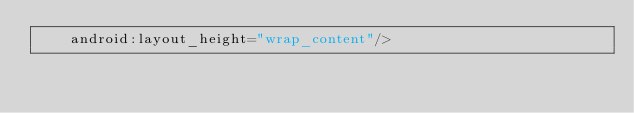<code> <loc_0><loc_0><loc_500><loc_500><_XML_>    android:layout_height="wrap_content"/>
</code> 